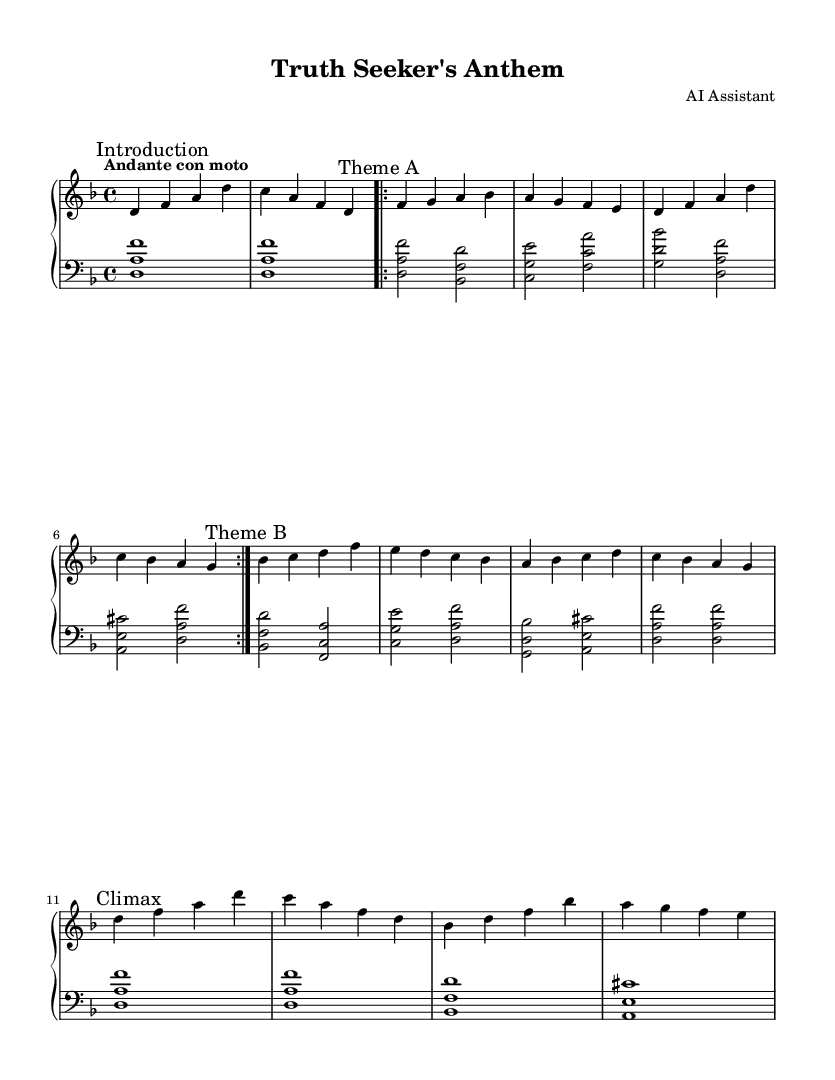What is the key signature of this music? The key signature indicates that the music is in D minor, which has one flat (B♭). This can be confirmed by looking at the key signature indicated at the beginning of the staff.
Answer: D minor What is the time signature of this music? The time signature is 4/4, which means there are four beats in each measure and the quarter note gets one beat. This is indicated near the beginning of the sheet music.
Answer: 4/4 What is the tempo marking of this piece? The tempo marking is "Andante con moto," which suggests a moderately slow pace with a bit of movement. It can be found at the beginning of the piece written above the staff.
Answer: Andante con moto How many times is Theme A repeated? Theme A is repeated twice, as indicated by the "repeat volta 2" instruction in the music. This instructs the performer to play the section two times.
Answer: 2 What is the chord of the left hand during the Climax section? During the Climax section, the left hand plays the chord D major, which consists of the notes D, A, and F#. This can be inferred from the notes played during that section.
Answer: D major What is the structural format of this piece? The piece follows an A-B-A structure, where Theme A is played first, followed by Theme B, and finally Theme A is repeated again. Each section is labeled clearly in the sheet music.
Answer: A-B-A What mood does this soundtrack aim to convey? The mood aimed to convey is dramatic and introspective, reflecting the theme of truth-seeking associated with influential journalists. This can be inferred from the emotional content of the themes and tempo markings in the music.
Answer: Dramatic 